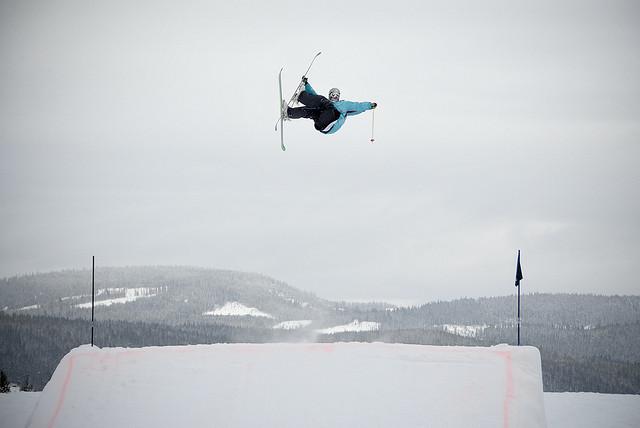Is the skier going to fall?
Concise answer only. Yes. Is it sunny?
Answer briefly. No. Who is in the air?
Keep it brief. Skier. What is this boy doing?
Give a very brief answer. Skiing. Is this person skiing?
Keep it brief. Yes. 